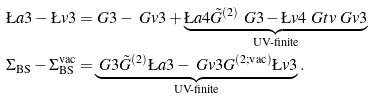<formula> <loc_0><loc_0><loc_500><loc_500>\L a { 3 } - \L v { 3 } = & \ G { 3 } - \ G v { 3 } + \underbrace { \L a { 4 } \tilde { G } ^ { ( 2 ) } \ G { 3 } - \L v { 4 } \ G t v \ G v { 3 } } _ { \text {UV-finite} } \\ \Sigma _ { \text {BS} } - \Sigma _ { \text {BS} } ^ { \text {vac} } = & \underbrace { \ G { 3 } \tilde { G } ^ { ( 2 ) } \L a { 3 } - \ G v { 3 } G ^ { ( 2 ; \text {vac} ) } \L v { 3 } } _ { \text {UV-finite} } .</formula> 